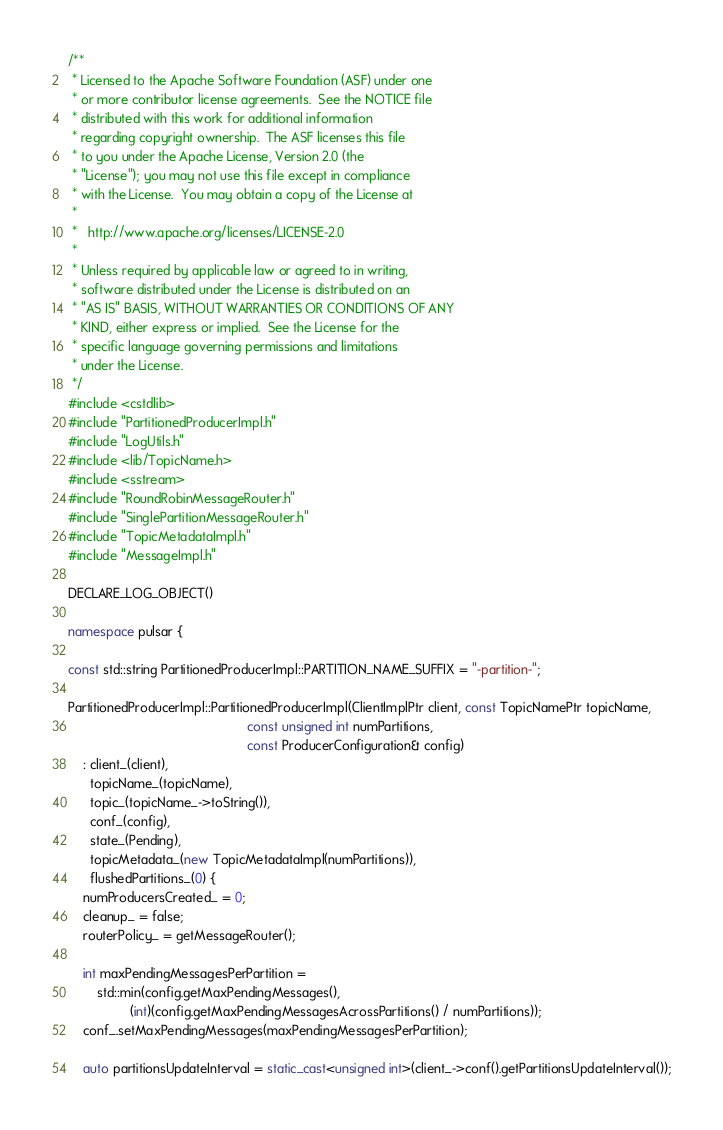<code> <loc_0><loc_0><loc_500><loc_500><_C++_>/**
 * Licensed to the Apache Software Foundation (ASF) under one
 * or more contributor license agreements.  See the NOTICE file
 * distributed with this work for additional information
 * regarding copyright ownership.  The ASF licenses this file
 * to you under the Apache License, Version 2.0 (the
 * "License"); you may not use this file except in compliance
 * with the License.  You may obtain a copy of the License at
 *
 *   http://www.apache.org/licenses/LICENSE-2.0
 *
 * Unless required by applicable law or agreed to in writing,
 * software distributed under the License is distributed on an
 * "AS IS" BASIS, WITHOUT WARRANTIES OR CONDITIONS OF ANY
 * KIND, either express or implied.  See the License for the
 * specific language governing permissions and limitations
 * under the License.
 */
#include <cstdlib>
#include "PartitionedProducerImpl.h"
#include "LogUtils.h"
#include <lib/TopicName.h>
#include <sstream>
#include "RoundRobinMessageRouter.h"
#include "SinglePartitionMessageRouter.h"
#include "TopicMetadataImpl.h"
#include "MessageImpl.h"

DECLARE_LOG_OBJECT()

namespace pulsar {

const std::string PartitionedProducerImpl::PARTITION_NAME_SUFFIX = "-partition-";

PartitionedProducerImpl::PartitionedProducerImpl(ClientImplPtr client, const TopicNamePtr topicName,
                                                 const unsigned int numPartitions,
                                                 const ProducerConfiguration& config)
    : client_(client),
      topicName_(topicName),
      topic_(topicName_->toString()),
      conf_(config),
      state_(Pending),
      topicMetadata_(new TopicMetadataImpl(numPartitions)),
      flushedPartitions_(0) {
    numProducersCreated_ = 0;
    cleanup_ = false;
    routerPolicy_ = getMessageRouter();

    int maxPendingMessagesPerPartition =
        std::min(config.getMaxPendingMessages(),
                 (int)(config.getMaxPendingMessagesAcrossPartitions() / numPartitions));
    conf_.setMaxPendingMessages(maxPendingMessagesPerPartition);

    auto partitionsUpdateInterval = static_cast<unsigned int>(client_->conf().getPartitionsUpdateInterval());</code> 